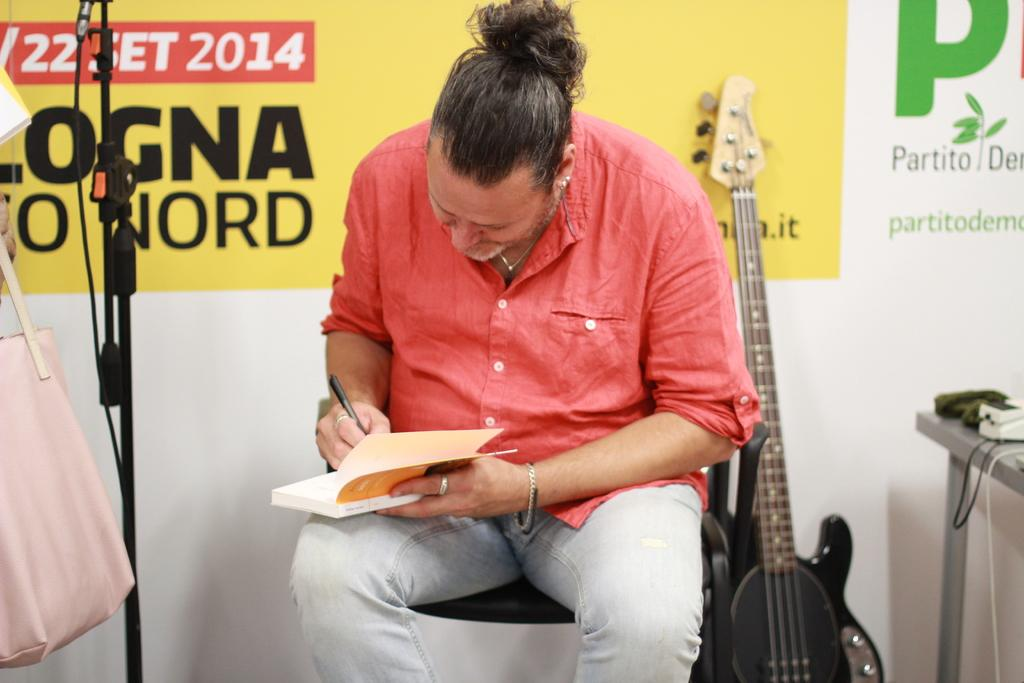Provide a one-sentence caption for the provided image. A man signing a book with a sign saying2014 behind him. 